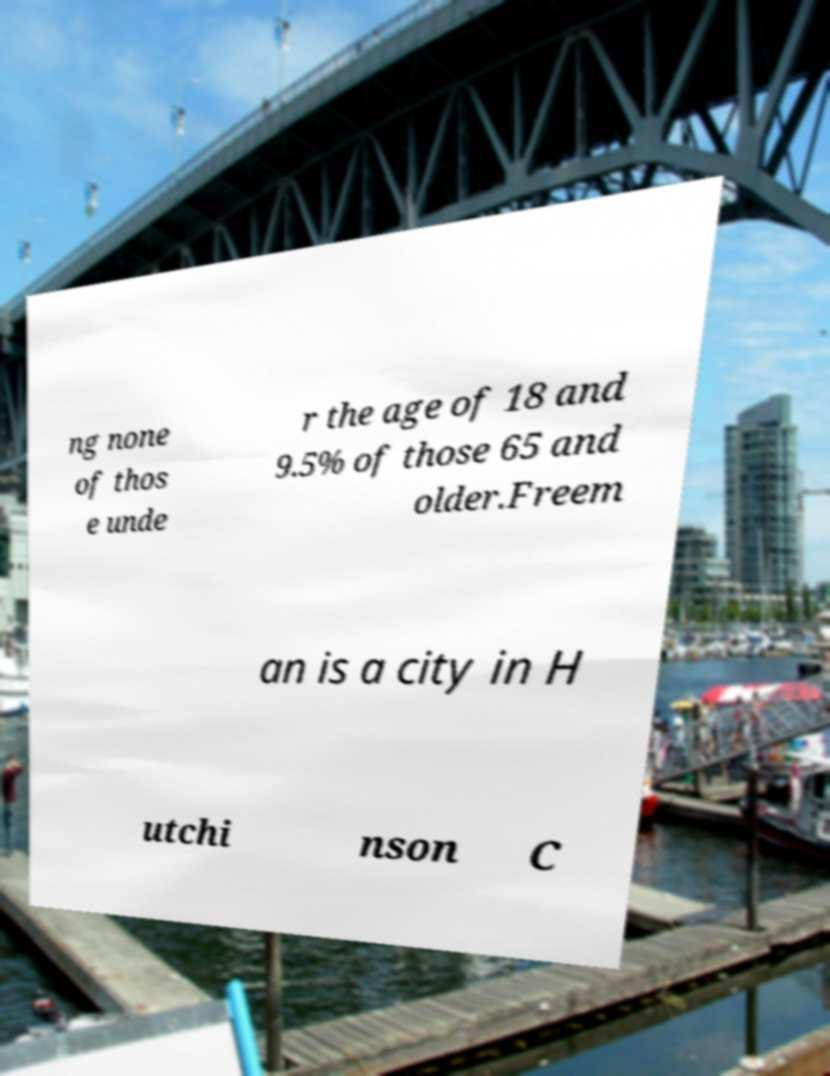Please read and relay the text visible in this image. What does it say? ng none of thos e unde r the age of 18 and 9.5% of those 65 and older.Freem an is a city in H utchi nson C 